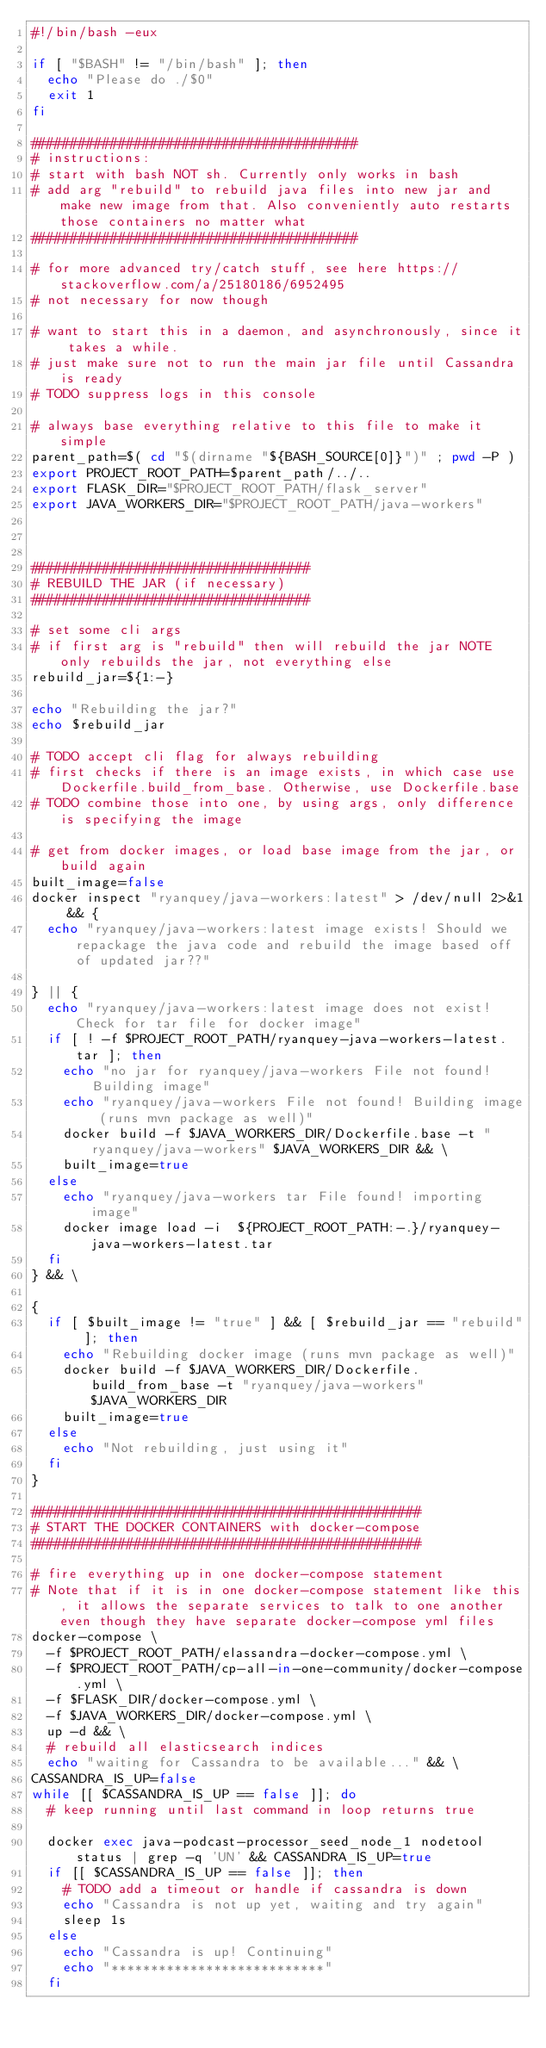Convert code to text. <code><loc_0><loc_0><loc_500><loc_500><_Bash_>#!/bin/bash -eux

if [ "$BASH" != "/bin/bash" ]; then
  echo "Please do ./$0"
  exit 1
fi

#########################################
# instructions: 
# start with bash NOT sh. Currently only works in bash
# add arg "rebuild" to rebuild java files into new jar and make new image from that. Also conveniently auto restarts those containers no matter what
#########################################

# for more advanced try/catch stuff, see here https://stackoverflow.com/a/25180186/6952495
# not necessary for now though

# want to start this in a daemon, and asynchronously, since it takes a while.
# just make sure not to run the main jar file until Cassandra is ready
# TODO suppress logs in this console

# always base everything relative to this file to make it simple
parent_path=$( cd "$(dirname "${BASH_SOURCE[0]}")" ; pwd -P )
export PROJECT_ROOT_PATH=$parent_path/../..
export FLASK_DIR="$PROJECT_ROOT_PATH/flask_server"
export JAVA_WORKERS_DIR="$PROJECT_ROOT_PATH/java-workers"



###################################
# REBUILD THE JAR (if necessary)
###################################

# set some cli args
# if first arg is "rebuild" then will rebuild the jar NOTE only rebuilds the jar, not everything else
rebuild_jar=${1:-}

echo "Rebuilding the jar?"
echo $rebuild_jar

# TODO accept cli flag for always rebuilding
# first checks if there is an image exists, in which case use Dockerfile.build_from_base. Otherwise, use Dockerfile.base
# TODO combine those into one, by using args, only difference is specifying the image

# get from docker images, or load base image from the jar, or build again
built_image=false
docker inspect "ryanquey/java-workers:latest" > /dev/null 2>&1 && {
  echo "ryanquey/java-workers:latest image exists! Should we repackage the java code and rebuild the image based off of updated jar??"

} || {
  echo "ryanquey/java-workers:latest image does not exist! Check for tar file for docker image"
  if [ ! -f $PROJECT_ROOT_PATH/ryanquey-java-workers-latest.tar ]; then
    echo "no jar for ryanquey/java-workers File not found! Building image"
    echo "ryanquey/java-workers File not found! Building image (runs mvn package as well)"
    docker build -f $JAVA_WORKERS_DIR/Dockerfile.base -t "ryanquey/java-workers" $JAVA_WORKERS_DIR && \
    built_image=true
  else
    echo "ryanquey/java-workers tar File found! importing image"
    docker image load -i  ${PROJECT_ROOT_PATH:-.}/ryanquey-java-workers-latest.tar
  fi
} && \

{
	if [ $built_image != "true" ] && [ $rebuild_jar == "rebuild" ]; then
    echo "Rebuilding docker image (runs mvn package as well)"
    docker build -f $JAVA_WORKERS_DIR/Dockerfile.build_from_base -t "ryanquey/java-workers" $JAVA_WORKERS_DIR
    built_image=true
  else 
    echo "Not rebuilding, just using it"
  fi
}

#################################################
# START THE DOCKER CONTAINERS with docker-compose
#################################################

# fire everything up in one docker-compose statement
# Note that if it is in one docker-compose statement like this, it allows the separate services to talk to one another even though they have separate docker-compose yml files
docker-compose \
  -f $PROJECT_ROOT_PATH/elassandra-docker-compose.yml \
  -f $PROJECT_ROOT_PATH/cp-all-in-one-community/docker-compose.yml \
  -f $FLASK_DIR/docker-compose.yml \
  -f $JAVA_WORKERS_DIR/docker-compose.yml \
  up -d && \
  # rebuild all elasticsearch indices
  echo "waiting for Cassandra to be available..." && \
CASSANDRA_IS_UP=false
while [[ $CASSANDRA_IS_UP == false ]]; do
  # keep running until last command in loop returns true

  docker exec java-podcast-processor_seed_node_1 nodetool status | grep -q 'UN' && CASSANDRA_IS_UP=true
  if [[ $CASSANDRA_IS_UP == false ]]; then
    # TODO add a timeout or handle if cassandra is down
  	echo "Cassandra is not up yet, waiting and try again"
  	sleep 1s
  else 
    echo "Cassandra is up! Continuing"
    echo "***************************"
  fi
</code> 